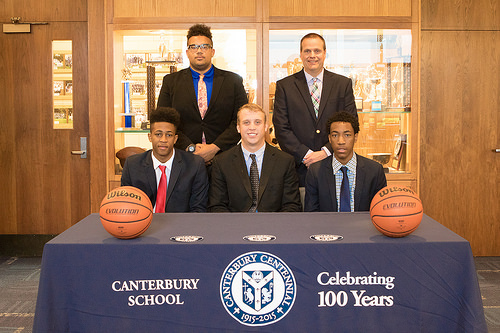<image>
Is there a middle man above the logo? No. The middle man is not positioned above the logo. The vertical arrangement shows a different relationship. 